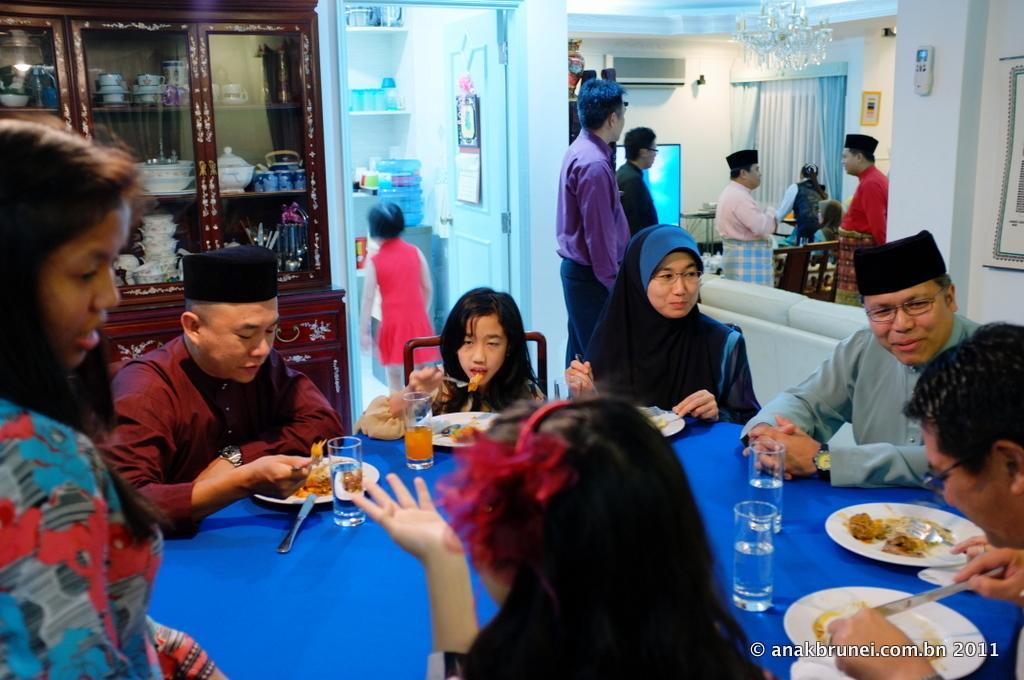Could you give a brief overview of what you see in this image? This is a picture inside of a house. In this image there are people, children, chairs, tables, walls, a glass cupboard, couch, screen, curtains, air conditioner, racks, chandelier and objects. In that glass cupboard there are cups, bowls and things. Among them few people are sitting, few people wore caps and few people are holding objects. In the front of the image we can see a group of people sitting on chairs, in-front of them there is a blue table, on the table there are water glasses, plates, food, a juice glass and objects. In that rock there are objects. We can see a remote, poster, picture and air conditioner on the walls. At the bottom right side of the image there is a watermark.   